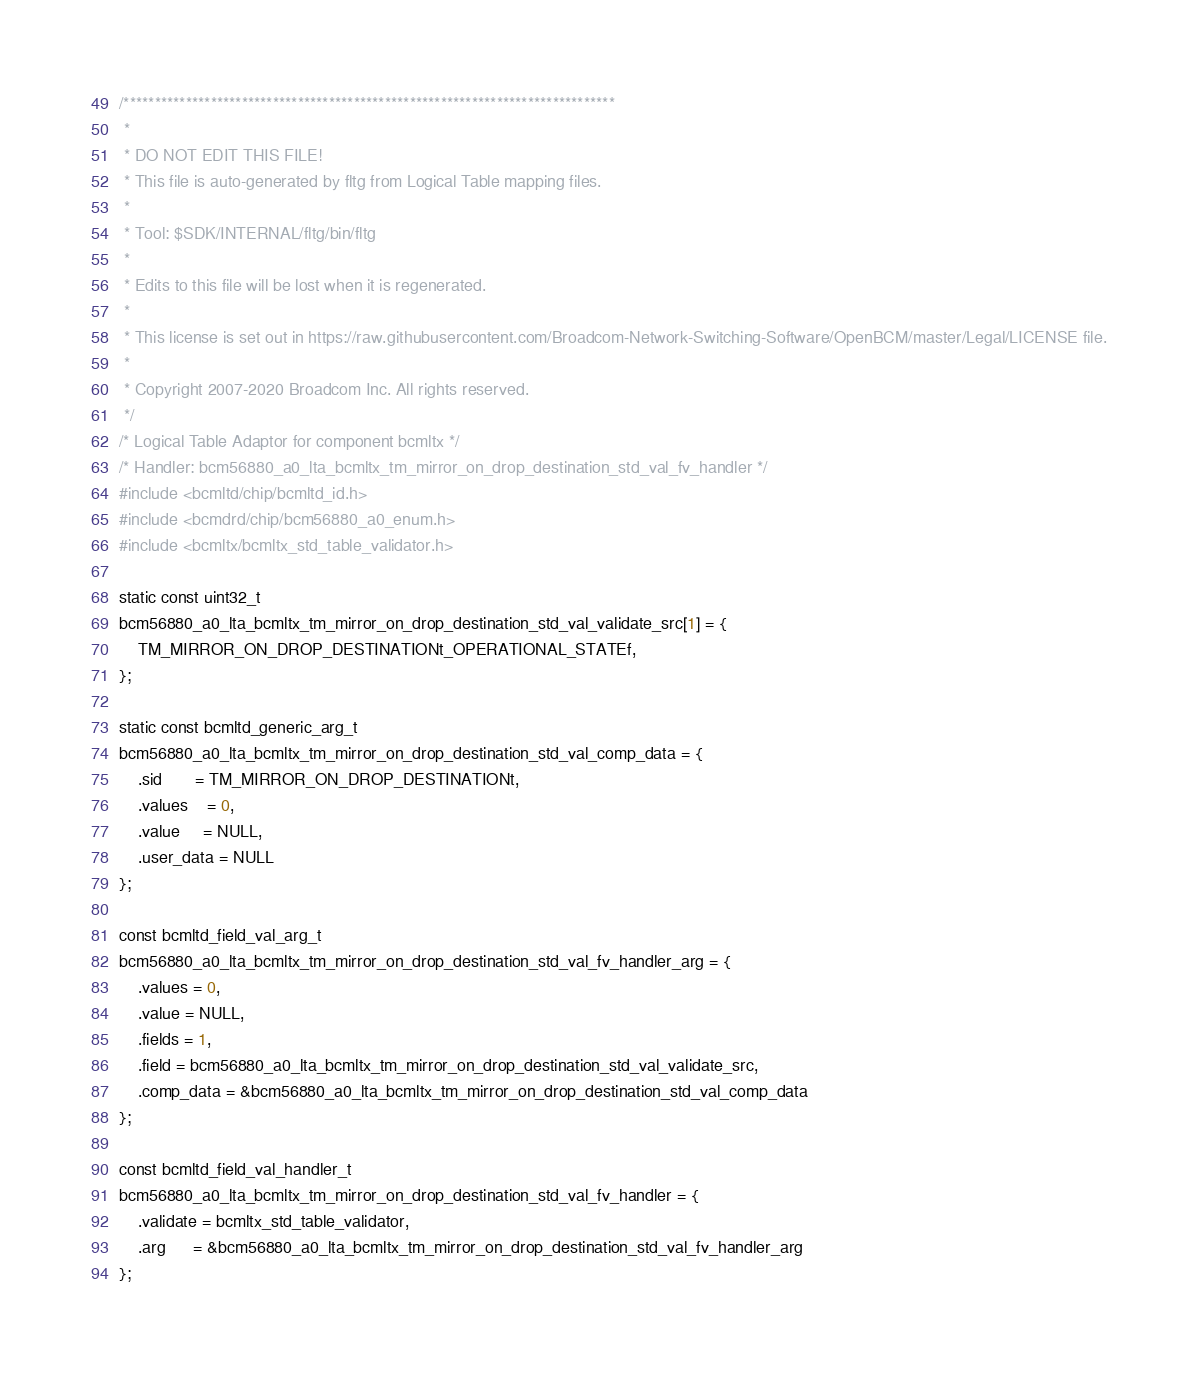Convert code to text. <code><loc_0><loc_0><loc_500><loc_500><_C_>/*******************************************************************************
 *
 * DO NOT EDIT THIS FILE!
 * This file is auto-generated by fltg from Logical Table mapping files.
 *
 * Tool: $SDK/INTERNAL/fltg/bin/fltg
 *
 * Edits to this file will be lost when it is regenerated.
 *
 * This license is set out in https://raw.githubusercontent.com/Broadcom-Network-Switching-Software/OpenBCM/master/Legal/LICENSE file.
 * 
 * Copyright 2007-2020 Broadcom Inc. All rights reserved.
 */
/* Logical Table Adaptor for component bcmltx */
/* Handler: bcm56880_a0_lta_bcmltx_tm_mirror_on_drop_destination_std_val_fv_handler */
#include <bcmltd/chip/bcmltd_id.h>
#include <bcmdrd/chip/bcm56880_a0_enum.h>
#include <bcmltx/bcmltx_std_table_validator.h>

static const uint32_t
bcm56880_a0_lta_bcmltx_tm_mirror_on_drop_destination_std_val_validate_src[1] = {
    TM_MIRROR_ON_DROP_DESTINATIONt_OPERATIONAL_STATEf,
};

static const bcmltd_generic_arg_t
bcm56880_a0_lta_bcmltx_tm_mirror_on_drop_destination_std_val_comp_data = {
    .sid       = TM_MIRROR_ON_DROP_DESTINATIONt,
    .values    = 0,
    .value     = NULL,
    .user_data = NULL
};

const bcmltd_field_val_arg_t
bcm56880_a0_lta_bcmltx_tm_mirror_on_drop_destination_std_val_fv_handler_arg = {
    .values = 0,
    .value = NULL,
    .fields = 1,
    .field = bcm56880_a0_lta_bcmltx_tm_mirror_on_drop_destination_std_val_validate_src,
    .comp_data = &bcm56880_a0_lta_bcmltx_tm_mirror_on_drop_destination_std_val_comp_data
};

const bcmltd_field_val_handler_t
bcm56880_a0_lta_bcmltx_tm_mirror_on_drop_destination_std_val_fv_handler = {
    .validate = bcmltx_std_table_validator,
    .arg      = &bcm56880_a0_lta_bcmltx_tm_mirror_on_drop_destination_std_val_fv_handler_arg
};


</code> 